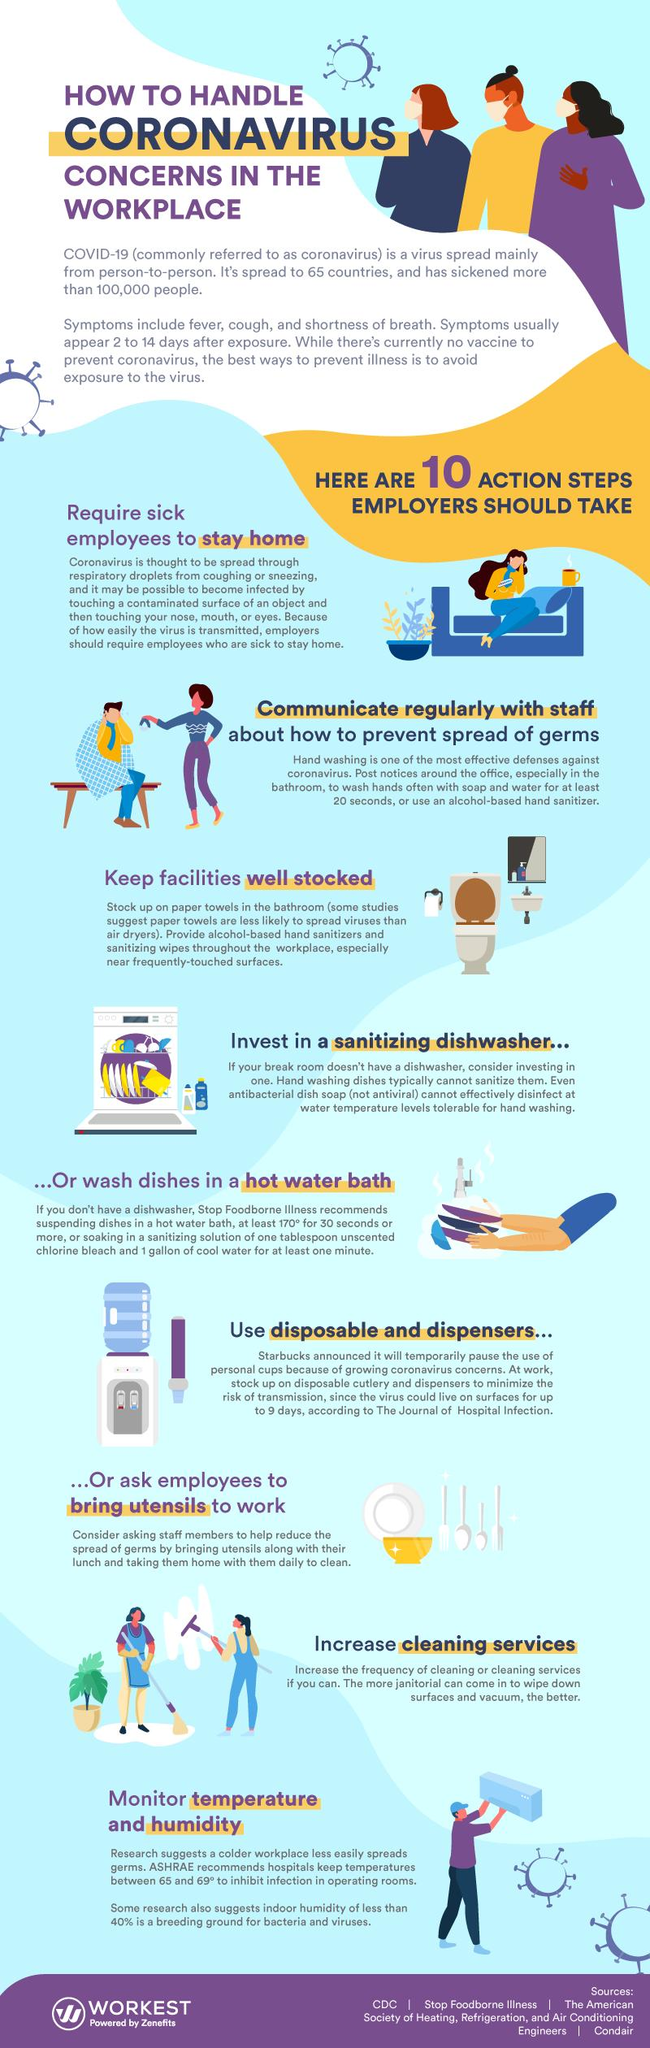Point out several critical features in this image. The infographic shows 9 people. The color of the bowl is yellow. 